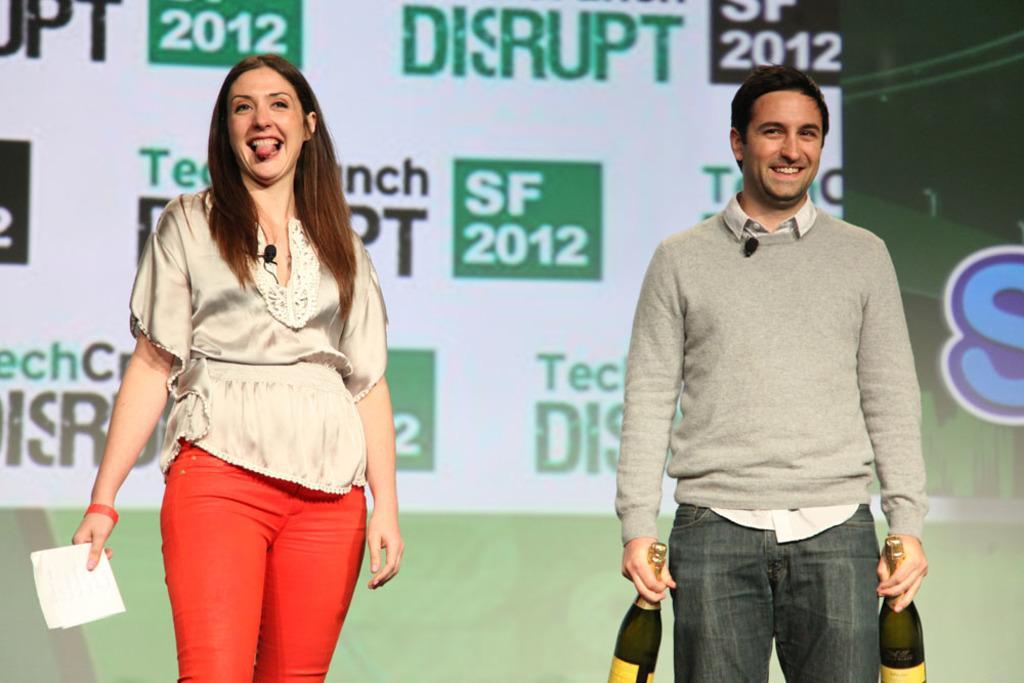Can you describe this image briefly? On the right side of the image a man is standing and holding the bottles in his hands. On the left side of the image a lady is standing and holding a paper in her hand. In the background of the image a board is there. 